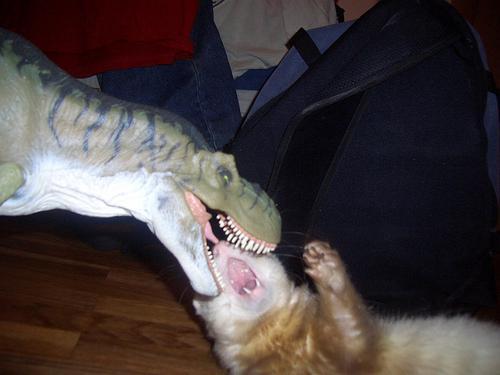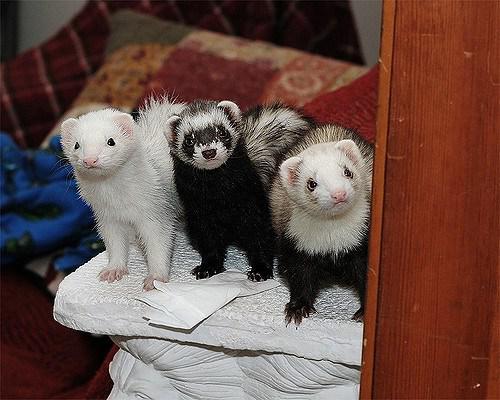The first image is the image on the left, the second image is the image on the right. Evaluate the accuracy of this statement regarding the images: "The right image contains exactly one ferret.". Is it true? Answer yes or no. No. The first image is the image on the left, the second image is the image on the right. For the images shown, is this caption "Some ferrets are in a container." true? Answer yes or no. No. 